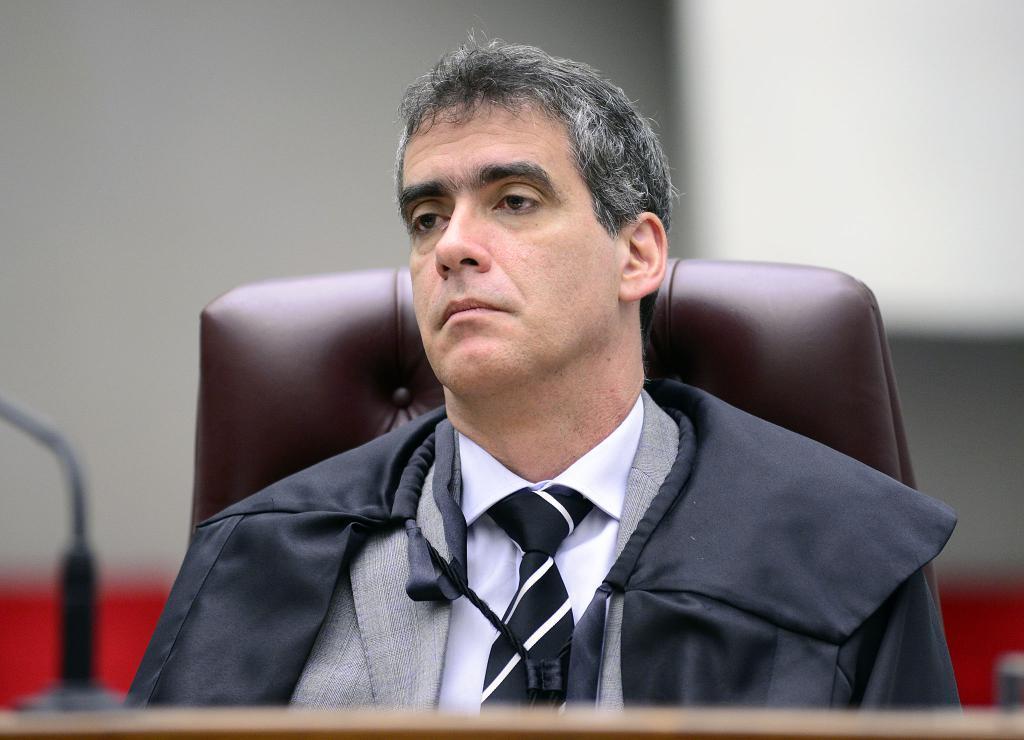Can you describe this image briefly? Here we can see a man is sitting on a chair and on the left there is a stand on a platform. In the background the image is blur but we can see a wall and a board. 